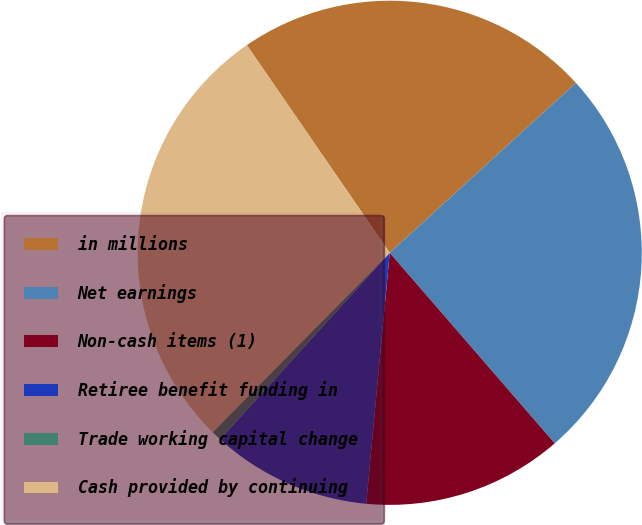Convert chart to OTSL. <chart><loc_0><loc_0><loc_500><loc_500><pie_chart><fcel>in millions<fcel>Net earnings<fcel>Non-cash items (1)<fcel>Retiree benefit funding in<fcel>Trade working capital change<fcel>Cash provided by continuing<nl><fcel>22.82%<fcel>25.41%<fcel>12.85%<fcel>10.26%<fcel>0.65%<fcel>28.01%<nl></chart> 